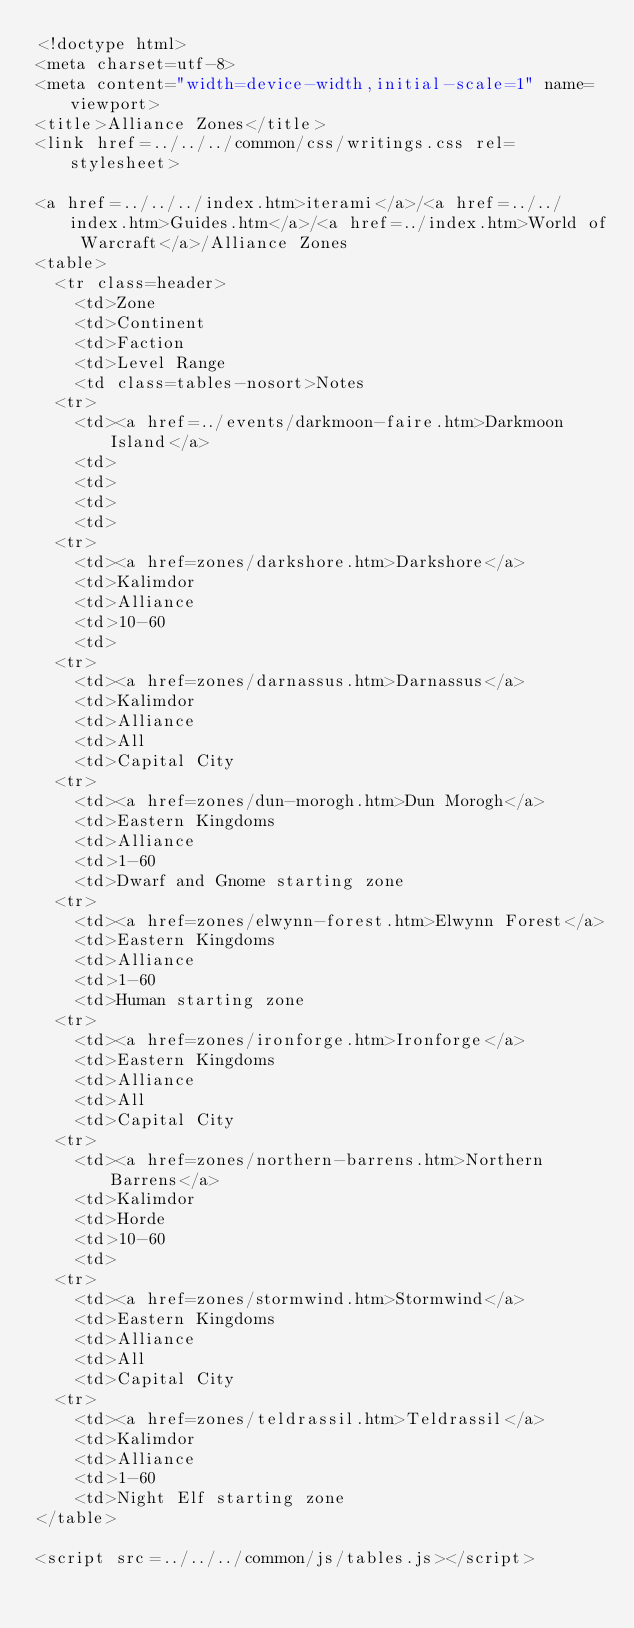Convert code to text. <code><loc_0><loc_0><loc_500><loc_500><_HTML_><!doctype html>
<meta charset=utf-8>
<meta content="width=device-width,initial-scale=1" name=viewport>
<title>Alliance Zones</title>
<link href=../../../common/css/writings.css rel=stylesheet>

<a href=../../../index.htm>iterami</a>/<a href=../../index.htm>Guides.htm</a>/<a href=../index.htm>World of Warcraft</a>/Alliance Zones
<table>
  <tr class=header>
    <td>Zone
    <td>Continent
    <td>Faction
    <td>Level Range
    <td class=tables-nosort>Notes
  <tr>
    <td><a href=../events/darkmoon-faire.htm>Darkmoon Island</a>
    <td>
    <td>
    <td>
    <td>
  <tr>
    <td><a href=zones/darkshore.htm>Darkshore</a>
    <td>Kalimdor
    <td>Alliance
    <td>10-60
    <td>
  <tr>
    <td><a href=zones/darnassus.htm>Darnassus</a>
    <td>Kalimdor
    <td>Alliance
    <td>All
    <td>Capital City
  <tr>
    <td><a href=zones/dun-morogh.htm>Dun Morogh</a>
    <td>Eastern Kingdoms
    <td>Alliance
    <td>1-60
    <td>Dwarf and Gnome starting zone
  <tr>
    <td><a href=zones/elwynn-forest.htm>Elwynn Forest</a>
    <td>Eastern Kingdoms
    <td>Alliance
    <td>1-60
    <td>Human starting zone
  <tr>
    <td><a href=zones/ironforge.htm>Ironforge</a>
    <td>Eastern Kingdoms
    <td>Alliance
    <td>All
    <td>Capital City
  <tr>
    <td><a href=zones/northern-barrens.htm>Northern Barrens</a>
    <td>Kalimdor
    <td>Horde
    <td>10-60
    <td>
  <tr>
    <td><a href=zones/stormwind.htm>Stormwind</a>
    <td>Eastern Kingdoms
    <td>Alliance
    <td>All
    <td>Capital City
  <tr>
    <td><a href=zones/teldrassil.htm>Teldrassil</a>
    <td>Kalimdor
    <td>Alliance
    <td>1-60
    <td>Night Elf starting zone
</table>

<script src=../../../common/js/tables.js></script>
</code> 